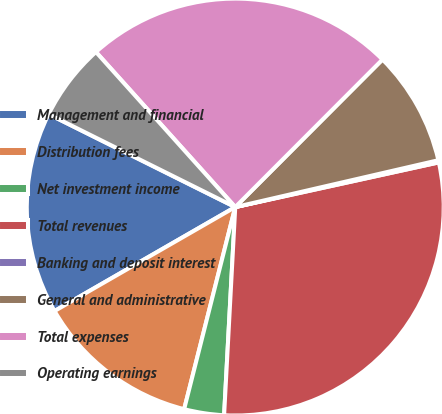<chart> <loc_0><loc_0><loc_500><loc_500><pie_chart><fcel>Management and financial<fcel>Distribution fees<fcel>Net investment income<fcel>Total revenues<fcel>Banking and deposit interest<fcel>General and administrative<fcel>Total expenses<fcel>Operating earnings<nl><fcel>15.66%<fcel>12.75%<fcel>3.09%<fcel>29.29%<fcel>0.17%<fcel>8.91%<fcel>24.13%<fcel>6.0%<nl></chart> 